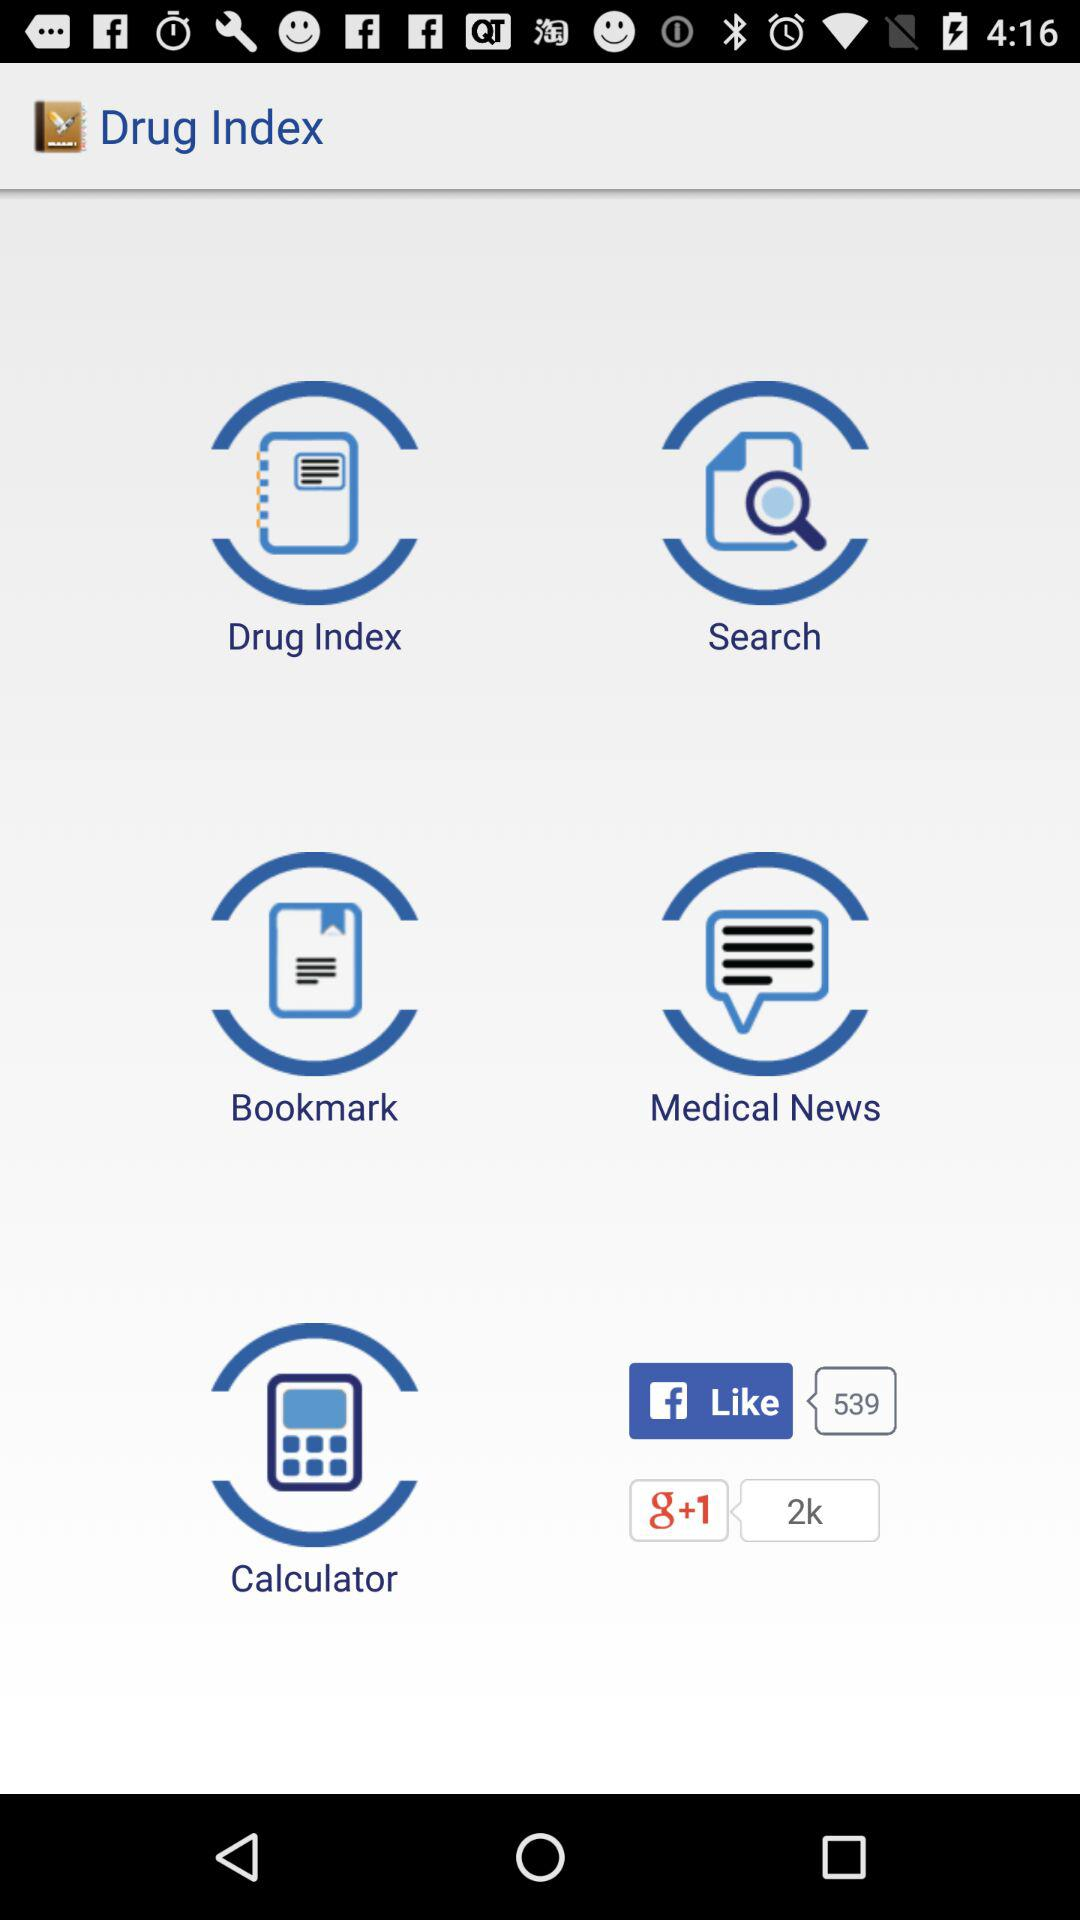How many likes on "Google+"? The likes on "Google+" are 2k. 